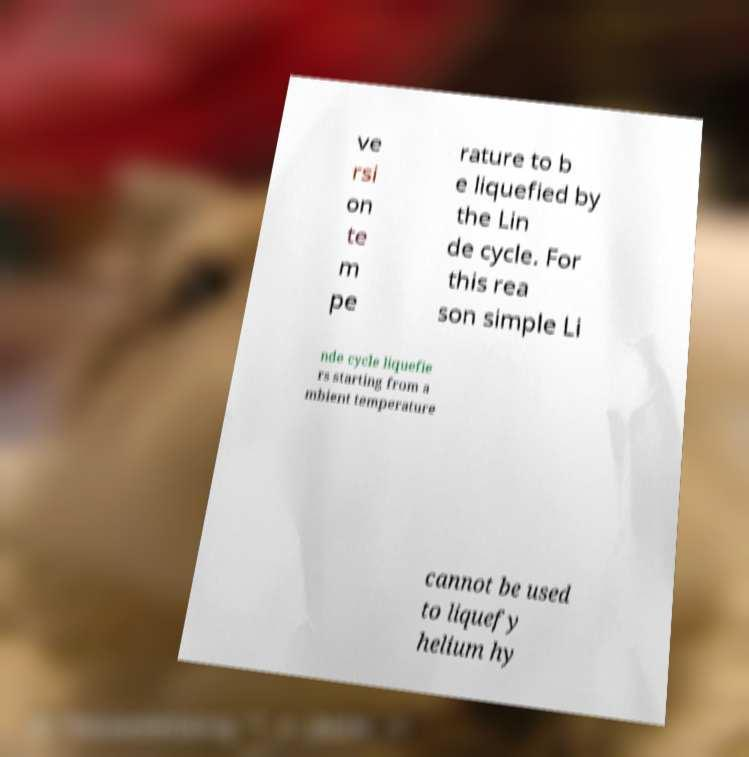Can you read and provide the text displayed in the image?This photo seems to have some interesting text. Can you extract and type it out for me? ve rsi on te m pe rature to b e liquefied by the Lin de cycle. For this rea son simple Li nde cycle liquefie rs starting from a mbient temperature cannot be used to liquefy helium hy 